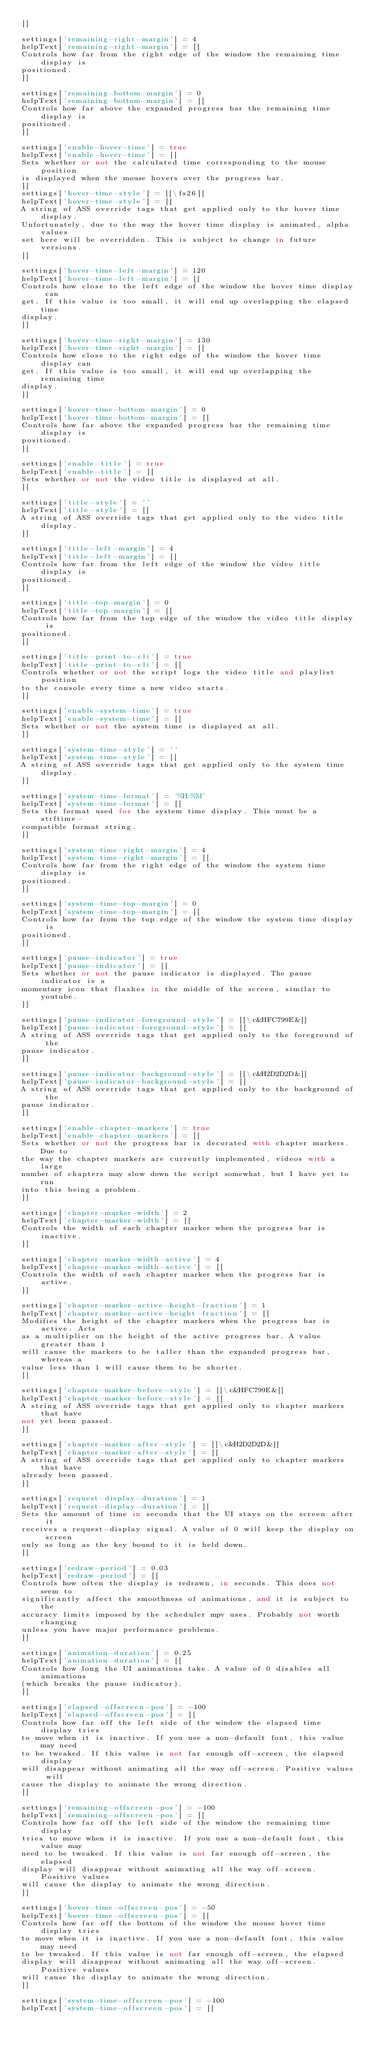<code> <loc_0><loc_0><loc_500><loc_500><_MoonScript_>]]

settings['remaining-right-margin'] = 4
helpText['remaining-right-margin'] = [[
Controls how far from the right edge of the window the remaining time display is
positioned.
]]

settings['remaining-bottom-margin'] = 0
helpText['remaining-bottom-margin'] = [[
Controls how far above the expanded progress bar the remaining time display is
positioned.
]]

settings['enable-hover-time'] = true
helpText['enable-hover-time'] = [[
Sets whether or not the calculated time corresponding to the mouse position
is displayed when the mouse hovers over the progress bar.
]]
settings['hover-time-style'] = [[\fs26]]
helpText['hover-time-style'] = [[
A string of ASS override tags that get applied only to the hover time display.
Unfortunately, due to the way the hover time display is animated, alpha values
set here will be overridden. This is subject to change in future versions.
]]

settings['hover-time-left-margin'] = 120
helpText['hover-time-left-margin'] = [[
Controls how close to the left edge of the window the hover time display can
get. If this value is too small, it will end up overlapping the elapsed time
display.
]]

settings['hover-time-right-margin'] = 130
helpText['hover-time-right-margin'] = [[
Controls how close to the right edge of the window the hover time display can
get. If this value is too small, it will end up overlapping the remaining time
display.
]]

settings['hover-time-bottom-margin'] = 0
helpText['hover-time-bottom-margin'] = [[
Controls how far above the expanded progress bar the remaining time display is
positioned.
]]

settings['enable-title'] = true
helpText['enable-title'] = [[
Sets whether or not the video title is displayed at all.
]]

settings['title-style'] = ''
helpText['title-style'] = [[
A string of ASS override tags that get applied only to the video title display.
]]

settings['title-left-margin'] = 4
helpText['title-left-margin'] = [[
Controls how far from the left edge of the window the video title display is
positioned.
]]

settings['title-top-margin'] = 0
helpText['title-top-margin'] = [[
Controls how far from the top edge of the window the video title display is
positioned.
]]

settings['title-print-to-cli'] = true
helpText['title-print-to-cli'] = [[
Controls whether or not the script logs the video title and playlist position
to the console every time a new video starts.
]]

settings['enable-system-time'] = true
helpText['enable-system-time'] = [[
Sets whether or not the system time is displayed at all.
]]

settings['system-time-style'] = ''
helpText['system-time-style'] = [[
A string of ASS override tags that get applied only to the system time display.
]]

settings['system-time-format'] = '%H:%M'
helpText['system-time-format'] = [[
Sets the format used for the system time display. This must be a strftime-
compatible format string.
]]

settings['system-time-right-margin'] = 4
helpText['system-time-right-margin'] = [[
Controls how far from the right edge of the window the system time display is
positioned.
]]

settings['system-time-top-margin'] = 0
helpText['system-time-top-margin'] = [[
Controls how far from the top edge of the window the system time display is
positioned.
]]

settings['pause-indicator'] = true
helpText['pause-indicator'] = [[
Sets whether or not the pause indicator is displayed. The pause indicator is a
momentary icon that flashes in the middle of the screen, similar to youtube.
]]

settings['pause-indicator-foreground-style'] = [[\c&HFC799E&]]
helpText['pause-indicator-foreground-style'] = [[
A string of ASS override tags that get applied only to the foreground of the
pause indicator.
]]

settings['pause-indicator-background-style'] = [[\c&H2D2D2D&]]
helpText['pause-indicator-background-style'] = [[
A string of ASS override tags that get applied only to the background of the
pause indicator.
]]

settings['enable-chapter-markers'] = true
helpText['enable-chapter-markers'] = [[
Sets whether or not the progress bar is decorated with chapter markers. Due to
the way the chapter markers are currently implemented, videos with a large
number of chapters may slow down the script somewhat, but I have yet to run
into this being a problem.
]]

settings['chapter-marker-width'] = 2
helpText['chapter-marker-width'] = [[
Controls the width of each chapter marker when the progress bar is inactive.
]]

settings['chapter-marker-width-active'] = 4
helpText['chapter-marker-width-active'] = [[
Controls the width of each chapter marker when the progress bar is active.
]]

settings['chapter-marker-active-height-fraction'] = 1
helpText['chapter-marker-active-height-fraction'] = [[
Modifies the height of the chapter markers when the progress bar is active. Acts
as a multiplier on the height of the active progress bar. A value greater than 1
will cause the markers to be taller than the expanded progress bar, whereas a
value less than 1 will cause them to be shorter.
]]

settings['chapter-marker-before-style'] = [[\c&HFC799E&]]
helpText['chapter-marker-before-style'] = [[
A string of ASS override tags that get applied only to chapter markers that have
not yet been passed.
]]

settings['chapter-marker-after-style'] = [[\c&H2D2D2D&]]
helpText['chapter-marker-after-style'] = [[
A string of ASS override tags that get applied only to chapter markers that have
already been passed.
]]

settings['request-display-duration'] = 1
helpText['request-display-duration'] = [[
Sets the amount of time in seconds that the UI stays on the screen after it
receives a request-display signal. A value of 0 will keep the display on screen
only as long as the key bound to it is held down.
]]

settings['redraw-period'] = 0.03
helpText['redraw-period'] = [[
Controls how often the display is redrawn, in seconds. This does not seem to
significantly affect the smoothness of animations, and it is subject to the
accuracy limits imposed by the scheduler mpv uses. Probably not worth changing
unless you have major performance problems.
]]

settings['animation-duration'] = 0.25
helpText['animation-duration'] = [[
Controls how long the UI animations take. A value of 0 disables all animations
(which breaks the pause indicator).
]]

settings['elapsed-offscreen-pos'] = -100
helpText['elapsed-offscreen-pos'] = [[
Controls how far off the left side of the window the elapsed time display tries
to move when it is inactive. If you use a non-default font, this value may need
to be tweaked. If this value is not far enough off-screen, the elapsed display
will disappear without animating all the way off-screen. Positive values will
cause the display to animate the wrong direction.
]]

settings['remaining-offscreen-pos'] = -100
helpText['remaining-offscreen-pos'] = [[
Controls how far off the left side of the window the remaining time display
tries to move when it is inactive. If you use a non-default font, this value may
need to be tweaked. If this value is not far enough off-screen, the elapsed
display will disappear without animating all the way off-screen. Positive values
will cause the display to animate the wrong direction.
]]

settings['hover-time-offscreen-pos'] = -50
helpText['hover-time-offscreen-pos'] = [[
Controls how far off the bottom of the window the mouse hover time display tries
to move when it is inactive. If you use a non-default font, this value may need
to be tweaked. If this value is not far enough off-screen, the elapsed
display will disappear without animating all the way off-screen. Positive values
will cause the display to animate the wrong direction.
]]

settings['system-time-offscreen-pos'] = -100
helpText['system-time-offscreen-pos'] = [[</code> 